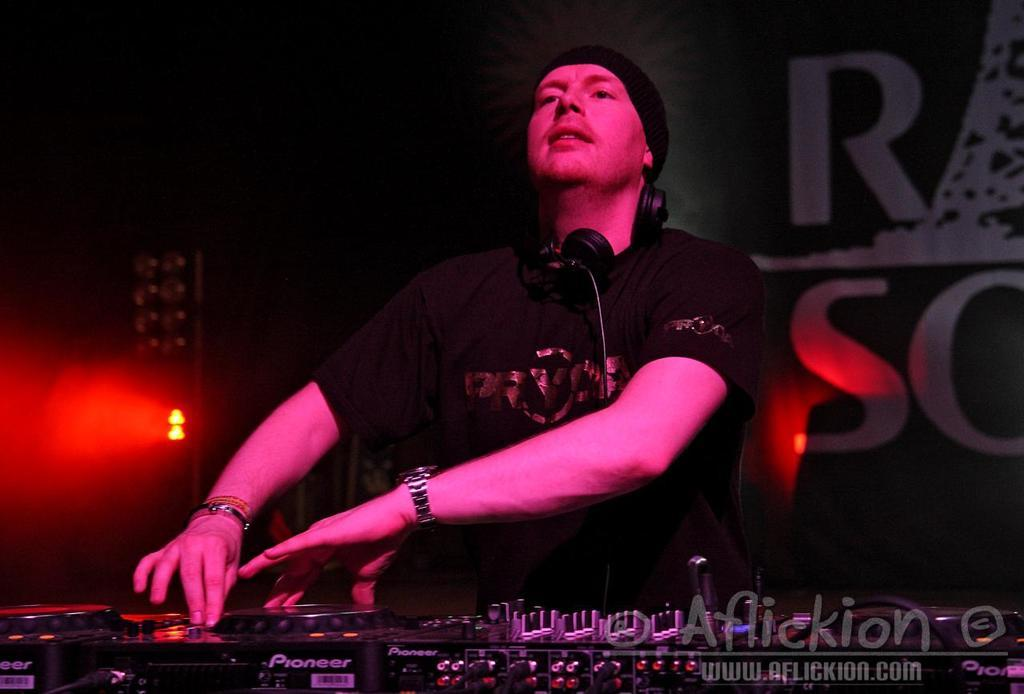What is the person in the image doing? A person is playing an instrument in the image. Can you describe anything in the background of the image? There is a focusing light in the distance. What type of accessory is visible on the person? A headset is visible in the image. Is there any text or marking at the bottom of the image? Yes, there is a watermark at the bottom of the image. How many actors are present in the image? There is no actor present in the image; it features a person playing an instrument. Can you tell me how many visitors are visible in the image? There is no visitor present in the image; it only shows a person playing an instrument and a focusing light in the background. 